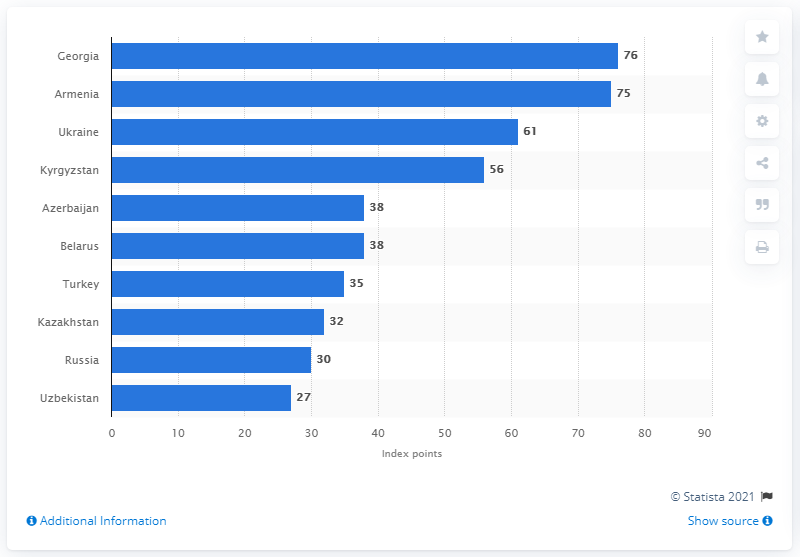Specify some key components in this picture. In 2020, Georgia's internet freedom score was 76, indicating a moderate level of internet freedom in the country. Uzbekistan scored 27 out of a possible 100 points in the given scenario. 